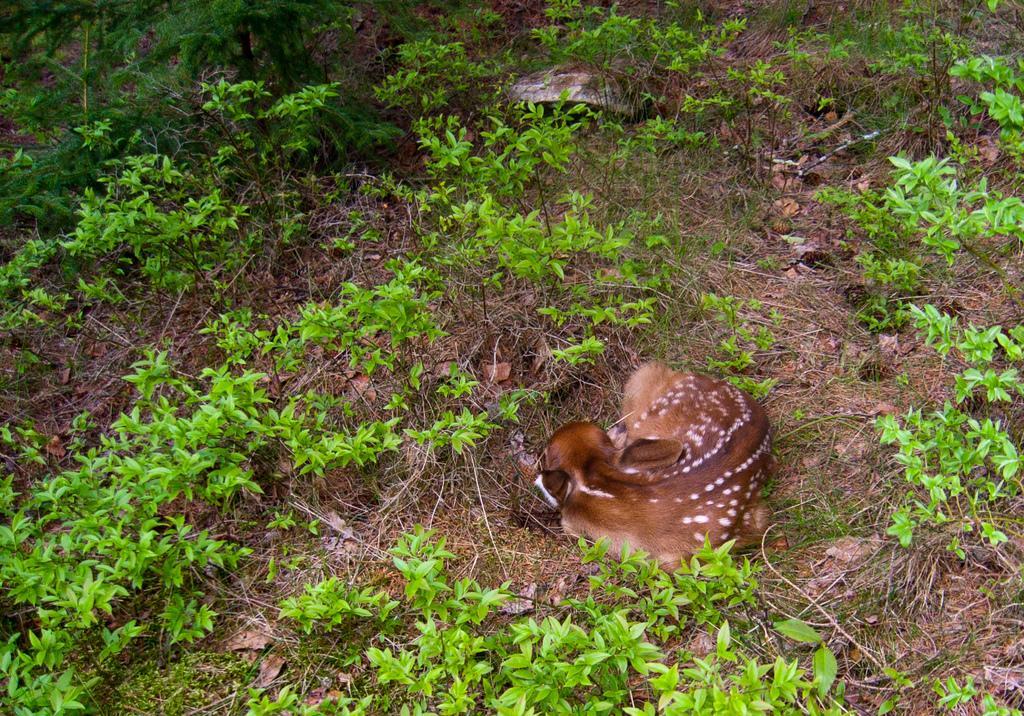How would you summarize this image in a sentence or two? In this image we can see a deer on the ground. Also there are few plants. 